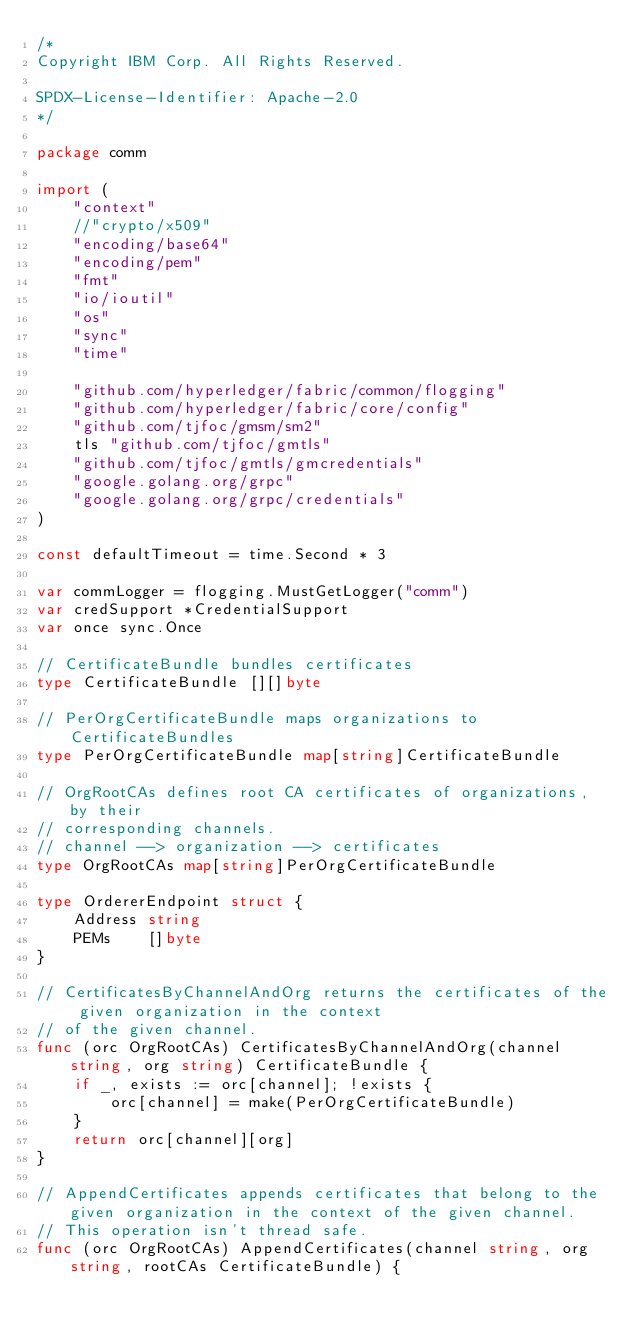Convert code to text. <code><loc_0><loc_0><loc_500><loc_500><_Go_>/*
Copyright IBM Corp. All Rights Reserved.

SPDX-License-Identifier: Apache-2.0
*/

package comm

import (
	"context"
	//"crypto/x509"
	"encoding/base64"
	"encoding/pem"
	"fmt"
	"io/ioutil"
	"os"
	"sync"
	"time"

	"github.com/hyperledger/fabric/common/flogging"
	"github.com/hyperledger/fabric/core/config"
	"github.com/tjfoc/gmsm/sm2"
	tls "github.com/tjfoc/gmtls"
	"github.com/tjfoc/gmtls/gmcredentials"
	"google.golang.org/grpc"
	"google.golang.org/grpc/credentials"
)

const defaultTimeout = time.Second * 3

var commLogger = flogging.MustGetLogger("comm")
var credSupport *CredentialSupport
var once sync.Once

// CertificateBundle bundles certificates
type CertificateBundle [][]byte

// PerOrgCertificateBundle maps organizations to CertificateBundles
type PerOrgCertificateBundle map[string]CertificateBundle

// OrgRootCAs defines root CA certificates of organizations, by their
// corresponding channels.
// channel --> organization --> certificates
type OrgRootCAs map[string]PerOrgCertificateBundle

type OrdererEndpoint struct {
	Address string
	PEMs    []byte
}

// CertificatesByChannelAndOrg returns the certificates of the given organization in the context
// of the given channel.
func (orc OrgRootCAs) CertificatesByChannelAndOrg(channel string, org string) CertificateBundle {
	if _, exists := orc[channel]; !exists {
		orc[channel] = make(PerOrgCertificateBundle)
	}
	return orc[channel][org]
}

// AppendCertificates appends certificates that belong to the given organization in the context of the given channel.
// This operation isn't thread safe.
func (orc OrgRootCAs) AppendCertificates(channel string, org string, rootCAs CertificateBundle) {</code> 